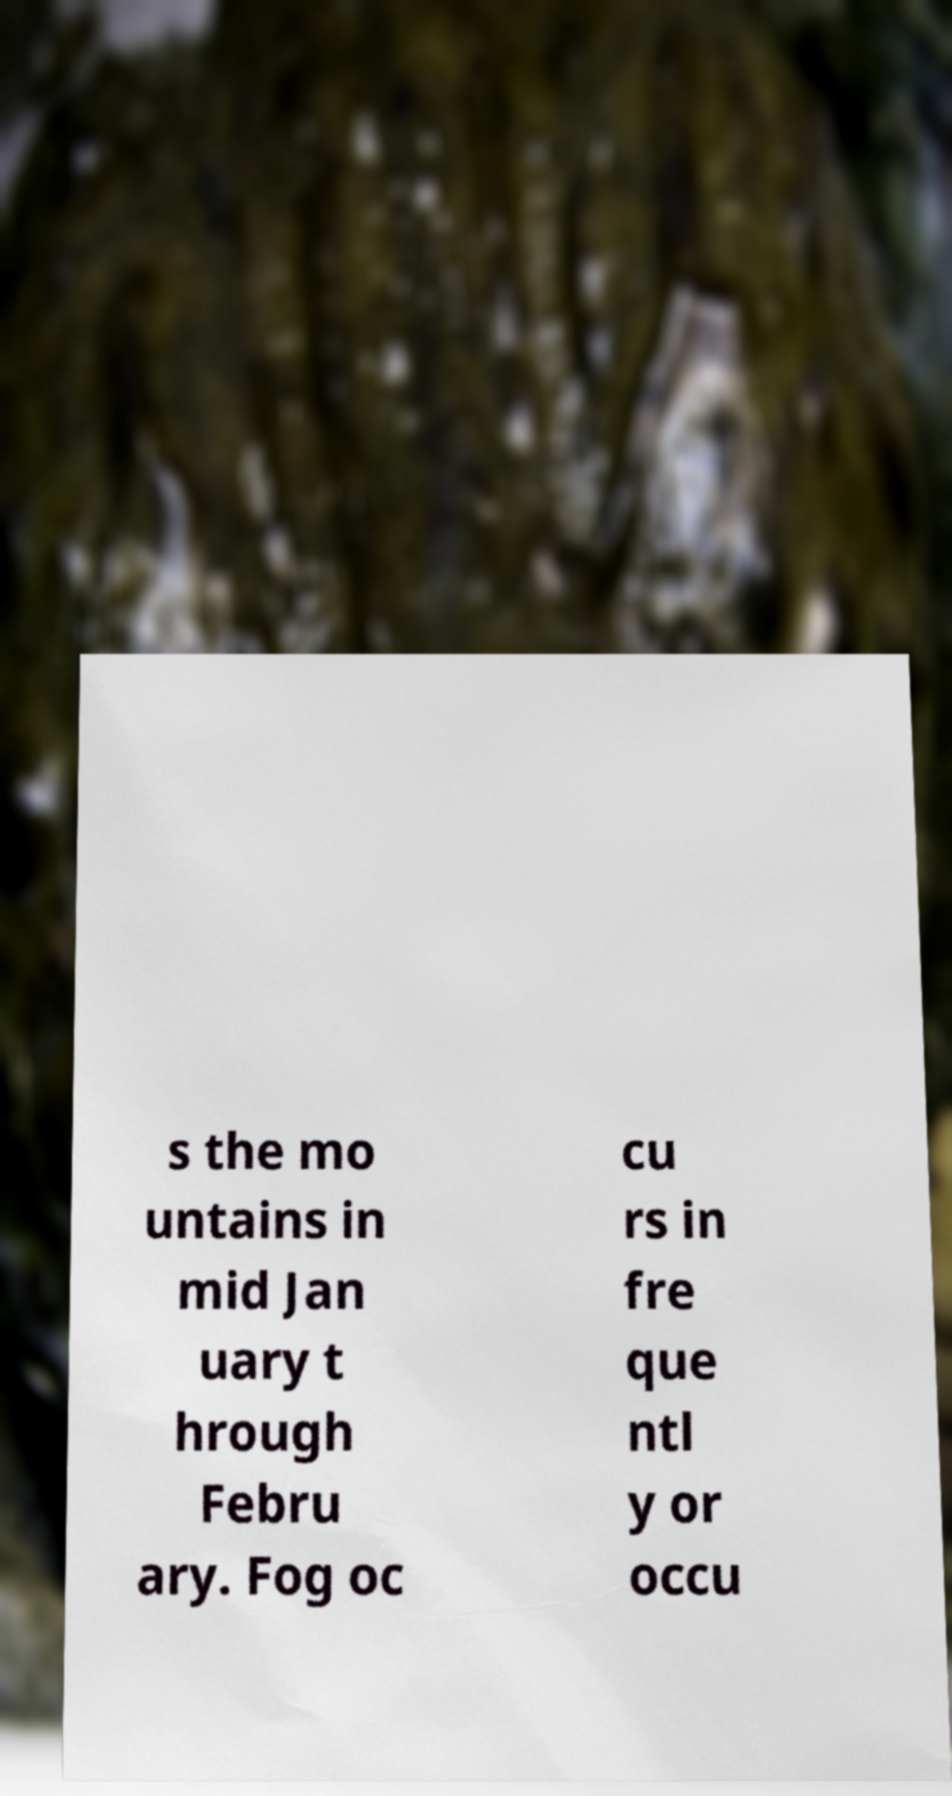What messages or text are displayed in this image? I need them in a readable, typed format. s the mo untains in mid Jan uary t hrough Febru ary. Fog oc cu rs in fre que ntl y or occu 